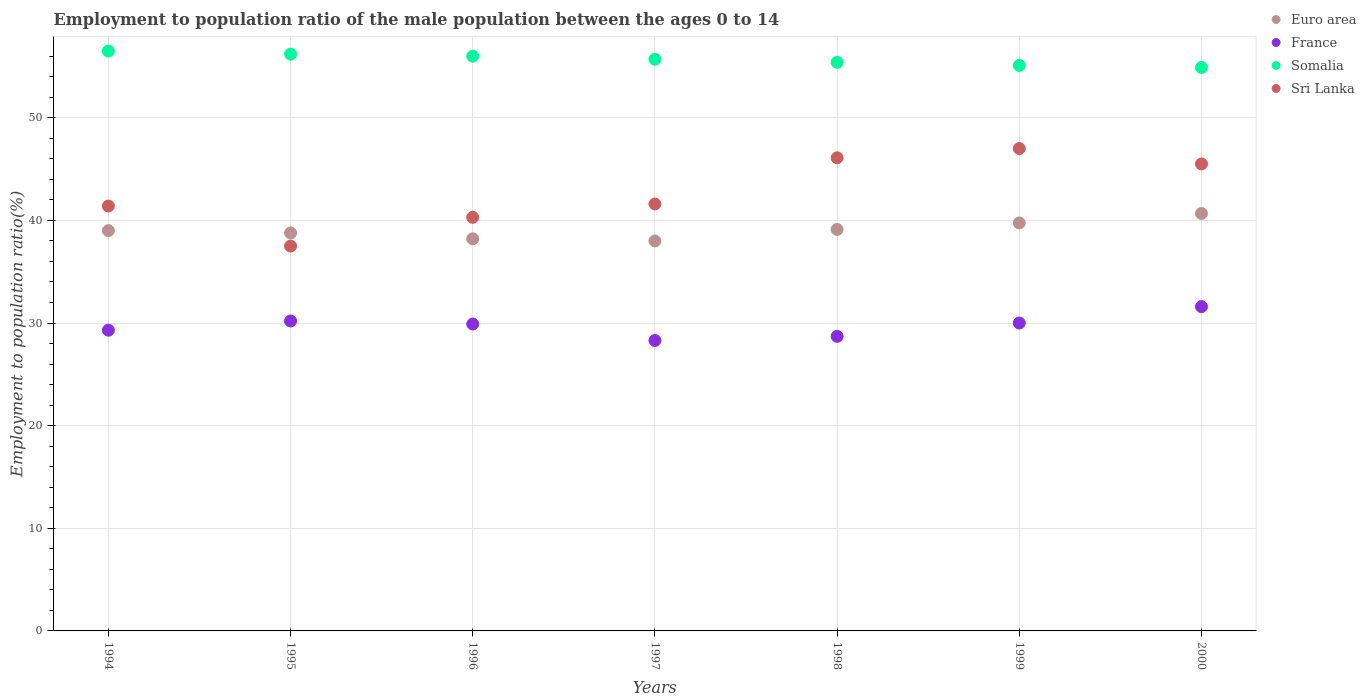Is the number of dotlines equal to the number of legend labels?
Give a very brief answer. Yes. What is the employment to population ratio in Euro area in 1998?
Provide a short and direct response. 39.12. Across all years, what is the maximum employment to population ratio in France?
Offer a very short reply. 31.6. Across all years, what is the minimum employment to population ratio in Euro area?
Your answer should be very brief. 38. In which year was the employment to population ratio in Euro area maximum?
Offer a terse response. 2000. In which year was the employment to population ratio in Euro area minimum?
Provide a short and direct response. 1997. What is the total employment to population ratio in Sri Lanka in the graph?
Your response must be concise. 299.4. What is the difference between the employment to population ratio in Somalia in 1998 and the employment to population ratio in Euro area in 1997?
Offer a very short reply. 17.4. What is the average employment to population ratio in France per year?
Offer a very short reply. 29.71. In the year 1994, what is the difference between the employment to population ratio in Sri Lanka and employment to population ratio in France?
Keep it short and to the point. 12.1. What is the ratio of the employment to population ratio in Euro area in 1995 to that in 2000?
Your answer should be very brief. 0.95. Is the employment to population ratio in Euro area in 1994 less than that in 1999?
Offer a terse response. Yes. What is the difference between the highest and the second highest employment to population ratio in Somalia?
Provide a short and direct response. 0.3. What is the difference between the highest and the lowest employment to population ratio in Euro area?
Your answer should be compact. 2.68. Is the sum of the employment to population ratio in Somalia in 1996 and 1999 greater than the maximum employment to population ratio in France across all years?
Ensure brevity in your answer.  Yes. Is it the case that in every year, the sum of the employment to population ratio in Sri Lanka and employment to population ratio in Euro area  is greater than the sum of employment to population ratio in Somalia and employment to population ratio in France?
Provide a succinct answer. Yes. Is the employment to population ratio in Somalia strictly greater than the employment to population ratio in Euro area over the years?
Give a very brief answer. Yes. Is the employment to population ratio in Euro area strictly less than the employment to population ratio in Somalia over the years?
Offer a terse response. Yes. Are the values on the major ticks of Y-axis written in scientific E-notation?
Give a very brief answer. No. Does the graph contain any zero values?
Ensure brevity in your answer.  No. How many legend labels are there?
Your answer should be very brief. 4. What is the title of the graph?
Provide a succinct answer. Employment to population ratio of the male population between the ages 0 to 14. What is the label or title of the Y-axis?
Offer a very short reply. Employment to population ratio(%). What is the Employment to population ratio(%) in Euro area in 1994?
Your answer should be compact. 39. What is the Employment to population ratio(%) in France in 1994?
Provide a short and direct response. 29.3. What is the Employment to population ratio(%) in Somalia in 1994?
Offer a terse response. 56.5. What is the Employment to population ratio(%) of Sri Lanka in 1994?
Give a very brief answer. 41.4. What is the Employment to population ratio(%) in Euro area in 1995?
Make the answer very short. 38.77. What is the Employment to population ratio(%) of France in 1995?
Give a very brief answer. 30.2. What is the Employment to population ratio(%) in Somalia in 1995?
Offer a very short reply. 56.2. What is the Employment to population ratio(%) in Sri Lanka in 1995?
Your answer should be very brief. 37.5. What is the Employment to population ratio(%) of Euro area in 1996?
Your answer should be compact. 38.21. What is the Employment to population ratio(%) in France in 1996?
Your response must be concise. 29.9. What is the Employment to population ratio(%) in Sri Lanka in 1996?
Ensure brevity in your answer.  40.3. What is the Employment to population ratio(%) of Euro area in 1997?
Offer a very short reply. 38. What is the Employment to population ratio(%) of France in 1997?
Keep it short and to the point. 28.3. What is the Employment to population ratio(%) in Somalia in 1997?
Keep it short and to the point. 55.7. What is the Employment to population ratio(%) of Sri Lanka in 1997?
Offer a terse response. 41.6. What is the Employment to population ratio(%) of Euro area in 1998?
Provide a succinct answer. 39.12. What is the Employment to population ratio(%) of France in 1998?
Give a very brief answer. 28.7. What is the Employment to population ratio(%) of Somalia in 1998?
Provide a succinct answer. 55.4. What is the Employment to population ratio(%) of Sri Lanka in 1998?
Offer a terse response. 46.1. What is the Employment to population ratio(%) in Euro area in 1999?
Your answer should be compact. 39.75. What is the Employment to population ratio(%) in Somalia in 1999?
Provide a succinct answer. 55.1. What is the Employment to population ratio(%) in Euro area in 2000?
Provide a succinct answer. 40.68. What is the Employment to population ratio(%) in France in 2000?
Provide a short and direct response. 31.6. What is the Employment to population ratio(%) in Somalia in 2000?
Give a very brief answer. 54.9. What is the Employment to population ratio(%) in Sri Lanka in 2000?
Provide a succinct answer. 45.5. Across all years, what is the maximum Employment to population ratio(%) of Euro area?
Give a very brief answer. 40.68. Across all years, what is the maximum Employment to population ratio(%) in France?
Give a very brief answer. 31.6. Across all years, what is the maximum Employment to population ratio(%) of Somalia?
Ensure brevity in your answer.  56.5. Across all years, what is the maximum Employment to population ratio(%) in Sri Lanka?
Provide a short and direct response. 47. Across all years, what is the minimum Employment to population ratio(%) of Euro area?
Give a very brief answer. 38. Across all years, what is the minimum Employment to population ratio(%) of France?
Offer a very short reply. 28.3. Across all years, what is the minimum Employment to population ratio(%) in Somalia?
Your answer should be very brief. 54.9. Across all years, what is the minimum Employment to population ratio(%) of Sri Lanka?
Offer a terse response. 37.5. What is the total Employment to population ratio(%) of Euro area in the graph?
Keep it short and to the point. 273.52. What is the total Employment to population ratio(%) of France in the graph?
Your answer should be compact. 208. What is the total Employment to population ratio(%) in Somalia in the graph?
Ensure brevity in your answer.  389.8. What is the total Employment to population ratio(%) of Sri Lanka in the graph?
Offer a terse response. 299.4. What is the difference between the Employment to population ratio(%) of Euro area in 1994 and that in 1995?
Provide a succinct answer. 0.23. What is the difference between the Employment to population ratio(%) in Somalia in 1994 and that in 1995?
Offer a very short reply. 0.3. What is the difference between the Employment to population ratio(%) of Euro area in 1994 and that in 1996?
Your response must be concise. 0.8. What is the difference between the Employment to population ratio(%) of France in 1994 and that in 1996?
Make the answer very short. -0.6. What is the difference between the Employment to population ratio(%) of Euro area in 1994 and that in 1997?
Provide a succinct answer. 1.01. What is the difference between the Employment to population ratio(%) in France in 1994 and that in 1997?
Provide a short and direct response. 1. What is the difference between the Employment to population ratio(%) in Sri Lanka in 1994 and that in 1997?
Provide a short and direct response. -0.2. What is the difference between the Employment to population ratio(%) of Euro area in 1994 and that in 1998?
Your answer should be very brief. -0.12. What is the difference between the Employment to population ratio(%) of Euro area in 1994 and that in 1999?
Your answer should be very brief. -0.75. What is the difference between the Employment to population ratio(%) in Somalia in 1994 and that in 1999?
Provide a succinct answer. 1.4. What is the difference between the Employment to population ratio(%) of Euro area in 1994 and that in 2000?
Ensure brevity in your answer.  -1.67. What is the difference between the Employment to population ratio(%) of France in 1994 and that in 2000?
Ensure brevity in your answer.  -2.3. What is the difference between the Employment to population ratio(%) in Somalia in 1994 and that in 2000?
Offer a terse response. 1.6. What is the difference between the Employment to population ratio(%) of Sri Lanka in 1994 and that in 2000?
Make the answer very short. -4.1. What is the difference between the Employment to population ratio(%) in Euro area in 1995 and that in 1996?
Give a very brief answer. 0.57. What is the difference between the Employment to population ratio(%) of France in 1995 and that in 1996?
Keep it short and to the point. 0.3. What is the difference between the Employment to population ratio(%) of Sri Lanka in 1995 and that in 1996?
Your response must be concise. -2.8. What is the difference between the Employment to population ratio(%) in Euro area in 1995 and that in 1997?
Your answer should be very brief. 0.78. What is the difference between the Employment to population ratio(%) of Euro area in 1995 and that in 1998?
Offer a terse response. -0.34. What is the difference between the Employment to population ratio(%) of Sri Lanka in 1995 and that in 1998?
Ensure brevity in your answer.  -8.6. What is the difference between the Employment to population ratio(%) in Euro area in 1995 and that in 1999?
Provide a succinct answer. -0.98. What is the difference between the Employment to population ratio(%) of France in 1995 and that in 1999?
Your response must be concise. 0.2. What is the difference between the Employment to population ratio(%) of Euro area in 1995 and that in 2000?
Give a very brief answer. -1.9. What is the difference between the Employment to population ratio(%) of France in 1995 and that in 2000?
Give a very brief answer. -1.4. What is the difference between the Employment to population ratio(%) in Euro area in 1996 and that in 1997?
Your answer should be very brief. 0.21. What is the difference between the Employment to population ratio(%) in France in 1996 and that in 1997?
Make the answer very short. 1.6. What is the difference between the Employment to population ratio(%) in Euro area in 1996 and that in 1998?
Provide a short and direct response. -0.91. What is the difference between the Employment to population ratio(%) of France in 1996 and that in 1998?
Your answer should be compact. 1.2. What is the difference between the Employment to population ratio(%) of Euro area in 1996 and that in 1999?
Your answer should be compact. -1.54. What is the difference between the Employment to population ratio(%) of Sri Lanka in 1996 and that in 1999?
Provide a succinct answer. -6.7. What is the difference between the Employment to population ratio(%) of Euro area in 1996 and that in 2000?
Keep it short and to the point. -2.47. What is the difference between the Employment to population ratio(%) in Somalia in 1996 and that in 2000?
Provide a succinct answer. 1.1. What is the difference between the Employment to population ratio(%) in Sri Lanka in 1996 and that in 2000?
Provide a short and direct response. -5.2. What is the difference between the Employment to population ratio(%) in Euro area in 1997 and that in 1998?
Provide a short and direct response. -1.12. What is the difference between the Employment to population ratio(%) in Somalia in 1997 and that in 1998?
Offer a very short reply. 0.3. What is the difference between the Employment to population ratio(%) in Euro area in 1997 and that in 1999?
Give a very brief answer. -1.76. What is the difference between the Employment to population ratio(%) of Euro area in 1997 and that in 2000?
Provide a short and direct response. -2.68. What is the difference between the Employment to population ratio(%) of France in 1997 and that in 2000?
Offer a very short reply. -3.3. What is the difference between the Employment to population ratio(%) in Euro area in 1998 and that in 1999?
Give a very brief answer. -0.63. What is the difference between the Employment to population ratio(%) of Somalia in 1998 and that in 1999?
Your answer should be very brief. 0.3. What is the difference between the Employment to population ratio(%) in Sri Lanka in 1998 and that in 1999?
Your answer should be compact. -0.9. What is the difference between the Employment to population ratio(%) of Euro area in 1998 and that in 2000?
Your answer should be very brief. -1.56. What is the difference between the Employment to population ratio(%) of France in 1998 and that in 2000?
Your answer should be compact. -2.9. What is the difference between the Employment to population ratio(%) of Sri Lanka in 1998 and that in 2000?
Ensure brevity in your answer.  0.6. What is the difference between the Employment to population ratio(%) in Euro area in 1999 and that in 2000?
Keep it short and to the point. -0.92. What is the difference between the Employment to population ratio(%) of Sri Lanka in 1999 and that in 2000?
Keep it short and to the point. 1.5. What is the difference between the Employment to population ratio(%) of Euro area in 1994 and the Employment to population ratio(%) of France in 1995?
Your answer should be compact. 8.8. What is the difference between the Employment to population ratio(%) in Euro area in 1994 and the Employment to population ratio(%) in Somalia in 1995?
Provide a succinct answer. -17.2. What is the difference between the Employment to population ratio(%) of Euro area in 1994 and the Employment to population ratio(%) of Sri Lanka in 1995?
Provide a succinct answer. 1.5. What is the difference between the Employment to population ratio(%) of France in 1994 and the Employment to population ratio(%) of Somalia in 1995?
Provide a succinct answer. -26.9. What is the difference between the Employment to population ratio(%) in Somalia in 1994 and the Employment to population ratio(%) in Sri Lanka in 1995?
Offer a very short reply. 19. What is the difference between the Employment to population ratio(%) in Euro area in 1994 and the Employment to population ratio(%) in France in 1996?
Provide a short and direct response. 9.1. What is the difference between the Employment to population ratio(%) of Euro area in 1994 and the Employment to population ratio(%) of Somalia in 1996?
Provide a succinct answer. -17. What is the difference between the Employment to population ratio(%) in Euro area in 1994 and the Employment to population ratio(%) in Sri Lanka in 1996?
Keep it short and to the point. -1.3. What is the difference between the Employment to population ratio(%) of France in 1994 and the Employment to population ratio(%) of Somalia in 1996?
Your answer should be compact. -26.7. What is the difference between the Employment to population ratio(%) of France in 1994 and the Employment to population ratio(%) of Sri Lanka in 1996?
Keep it short and to the point. -11. What is the difference between the Employment to population ratio(%) of Euro area in 1994 and the Employment to population ratio(%) of France in 1997?
Your answer should be very brief. 10.7. What is the difference between the Employment to population ratio(%) of Euro area in 1994 and the Employment to population ratio(%) of Somalia in 1997?
Offer a very short reply. -16.7. What is the difference between the Employment to population ratio(%) in Euro area in 1994 and the Employment to population ratio(%) in Sri Lanka in 1997?
Ensure brevity in your answer.  -2.6. What is the difference between the Employment to population ratio(%) of France in 1994 and the Employment to population ratio(%) of Somalia in 1997?
Your answer should be very brief. -26.4. What is the difference between the Employment to population ratio(%) of France in 1994 and the Employment to population ratio(%) of Sri Lanka in 1997?
Provide a short and direct response. -12.3. What is the difference between the Employment to population ratio(%) in Somalia in 1994 and the Employment to population ratio(%) in Sri Lanka in 1997?
Give a very brief answer. 14.9. What is the difference between the Employment to population ratio(%) of Euro area in 1994 and the Employment to population ratio(%) of France in 1998?
Your response must be concise. 10.3. What is the difference between the Employment to population ratio(%) in Euro area in 1994 and the Employment to population ratio(%) in Somalia in 1998?
Your response must be concise. -16.4. What is the difference between the Employment to population ratio(%) of Euro area in 1994 and the Employment to population ratio(%) of Sri Lanka in 1998?
Ensure brevity in your answer.  -7.1. What is the difference between the Employment to population ratio(%) of France in 1994 and the Employment to population ratio(%) of Somalia in 1998?
Offer a terse response. -26.1. What is the difference between the Employment to population ratio(%) of France in 1994 and the Employment to population ratio(%) of Sri Lanka in 1998?
Your answer should be compact. -16.8. What is the difference between the Employment to population ratio(%) in Somalia in 1994 and the Employment to population ratio(%) in Sri Lanka in 1998?
Give a very brief answer. 10.4. What is the difference between the Employment to population ratio(%) in Euro area in 1994 and the Employment to population ratio(%) in France in 1999?
Offer a very short reply. 9. What is the difference between the Employment to population ratio(%) in Euro area in 1994 and the Employment to population ratio(%) in Somalia in 1999?
Offer a very short reply. -16.1. What is the difference between the Employment to population ratio(%) of Euro area in 1994 and the Employment to population ratio(%) of Sri Lanka in 1999?
Provide a short and direct response. -8. What is the difference between the Employment to population ratio(%) in France in 1994 and the Employment to population ratio(%) in Somalia in 1999?
Keep it short and to the point. -25.8. What is the difference between the Employment to population ratio(%) in France in 1994 and the Employment to population ratio(%) in Sri Lanka in 1999?
Provide a succinct answer. -17.7. What is the difference between the Employment to population ratio(%) in Somalia in 1994 and the Employment to population ratio(%) in Sri Lanka in 1999?
Provide a succinct answer. 9.5. What is the difference between the Employment to population ratio(%) of Euro area in 1994 and the Employment to population ratio(%) of France in 2000?
Give a very brief answer. 7.4. What is the difference between the Employment to population ratio(%) in Euro area in 1994 and the Employment to population ratio(%) in Somalia in 2000?
Your response must be concise. -15.9. What is the difference between the Employment to population ratio(%) of Euro area in 1994 and the Employment to population ratio(%) of Sri Lanka in 2000?
Make the answer very short. -6.5. What is the difference between the Employment to population ratio(%) of France in 1994 and the Employment to population ratio(%) of Somalia in 2000?
Make the answer very short. -25.6. What is the difference between the Employment to population ratio(%) in France in 1994 and the Employment to population ratio(%) in Sri Lanka in 2000?
Offer a very short reply. -16.2. What is the difference between the Employment to population ratio(%) in Somalia in 1994 and the Employment to population ratio(%) in Sri Lanka in 2000?
Provide a short and direct response. 11. What is the difference between the Employment to population ratio(%) of Euro area in 1995 and the Employment to population ratio(%) of France in 1996?
Your response must be concise. 8.87. What is the difference between the Employment to population ratio(%) of Euro area in 1995 and the Employment to population ratio(%) of Somalia in 1996?
Your answer should be very brief. -17.23. What is the difference between the Employment to population ratio(%) in Euro area in 1995 and the Employment to population ratio(%) in Sri Lanka in 1996?
Your answer should be very brief. -1.53. What is the difference between the Employment to population ratio(%) of France in 1995 and the Employment to population ratio(%) of Somalia in 1996?
Your response must be concise. -25.8. What is the difference between the Employment to population ratio(%) in Somalia in 1995 and the Employment to population ratio(%) in Sri Lanka in 1996?
Provide a short and direct response. 15.9. What is the difference between the Employment to population ratio(%) of Euro area in 1995 and the Employment to population ratio(%) of France in 1997?
Your answer should be compact. 10.47. What is the difference between the Employment to population ratio(%) in Euro area in 1995 and the Employment to population ratio(%) in Somalia in 1997?
Make the answer very short. -16.93. What is the difference between the Employment to population ratio(%) in Euro area in 1995 and the Employment to population ratio(%) in Sri Lanka in 1997?
Offer a terse response. -2.83. What is the difference between the Employment to population ratio(%) of France in 1995 and the Employment to population ratio(%) of Somalia in 1997?
Ensure brevity in your answer.  -25.5. What is the difference between the Employment to population ratio(%) of France in 1995 and the Employment to population ratio(%) of Sri Lanka in 1997?
Your answer should be very brief. -11.4. What is the difference between the Employment to population ratio(%) of Somalia in 1995 and the Employment to population ratio(%) of Sri Lanka in 1997?
Keep it short and to the point. 14.6. What is the difference between the Employment to population ratio(%) of Euro area in 1995 and the Employment to population ratio(%) of France in 1998?
Provide a short and direct response. 10.07. What is the difference between the Employment to population ratio(%) of Euro area in 1995 and the Employment to population ratio(%) of Somalia in 1998?
Ensure brevity in your answer.  -16.63. What is the difference between the Employment to population ratio(%) of Euro area in 1995 and the Employment to population ratio(%) of Sri Lanka in 1998?
Provide a succinct answer. -7.33. What is the difference between the Employment to population ratio(%) of France in 1995 and the Employment to population ratio(%) of Somalia in 1998?
Provide a short and direct response. -25.2. What is the difference between the Employment to population ratio(%) in France in 1995 and the Employment to population ratio(%) in Sri Lanka in 1998?
Keep it short and to the point. -15.9. What is the difference between the Employment to population ratio(%) in Euro area in 1995 and the Employment to population ratio(%) in France in 1999?
Your answer should be very brief. 8.77. What is the difference between the Employment to population ratio(%) in Euro area in 1995 and the Employment to population ratio(%) in Somalia in 1999?
Your answer should be compact. -16.33. What is the difference between the Employment to population ratio(%) in Euro area in 1995 and the Employment to population ratio(%) in Sri Lanka in 1999?
Provide a succinct answer. -8.23. What is the difference between the Employment to population ratio(%) in France in 1995 and the Employment to population ratio(%) in Somalia in 1999?
Offer a very short reply. -24.9. What is the difference between the Employment to population ratio(%) of France in 1995 and the Employment to population ratio(%) of Sri Lanka in 1999?
Provide a succinct answer. -16.8. What is the difference between the Employment to population ratio(%) in Somalia in 1995 and the Employment to population ratio(%) in Sri Lanka in 1999?
Your answer should be compact. 9.2. What is the difference between the Employment to population ratio(%) in Euro area in 1995 and the Employment to population ratio(%) in France in 2000?
Make the answer very short. 7.17. What is the difference between the Employment to population ratio(%) in Euro area in 1995 and the Employment to population ratio(%) in Somalia in 2000?
Keep it short and to the point. -16.13. What is the difference between the Employment to population ratio(%) of Euro area in 1995 and the Employment to population ratio(%) of Sri Lanka in 2000?
Offer a very short reply. -6.73. What is the difference between the Employment to population ratio(%) of France in 1995 and the Employment to population ratio(%) of Somalia in 2000?
Offer a very short reply. -24.7. What is the difference between the Employment to population ratio(%) in France in 1995 and the Employment to population ratio(%) in Sri Lanka in 2000?
Offer a very short reply. -15.3. What is the difference between the Employment to population ratio(%) of Euro area in 1996 and the Employment to population ratio(%) of France in 1997?
Your answer should be very brief. 9.91. What is the difference between the Employment to population ratio(%) in Euro area in 1996 and the Employment to population ratio(%) in Somalia in 1997?
Offer a very short reply. -17.49. What is the difference between the Employment to population ratio(%) in Euro area in 1996 and the Employment to population ratio(%) in Sri Lanka in 1997?
Offer a very short reply. -3.39. What is the difference between the Employment to population ratio(%) in France in 1996 and the Employment to population ratio(%) in Somalia in 1997?
Provide a succinct answer. -25.8. What is the difference between the Employment to population ratio(%) of France in 1996 and the Employment to population ratio(%) of Sri Lanka in 1997?
Ensure brevity in your answer.  -11.7. What is the difference between the Employment to population ratio(%) in Somalia in 1996 and the Employment to population ratio(%) in Sri Lanka in 1997?
Your answer should be compact. 14.4. What is the difference between the Employment to population ratio(%) in Euro area in 1996 and the Employment to population ratio(%) in France in 1998?
Your response must be concise. 9.51. What is the difference between the Employment to population ratio(%) in Euro area in 1996 and the Employment to population ratio(%) in Somalia in 1998?
Make the answer very short. -17.19. What is the difference between the Employment to population ratio(%) in Euro area in 1996 and the Employment to population ratio(%) in Sri Lanka in 1998?
Provide a succinct answer. -7.89. What is the difference between the Employment to population ratio(%) of France in 1996 and the Employment to population ratio(%) of Somalia in 1998?
Offer a terse response. -25.5. What is the difference between the Employment to population ratio(%) in France in 1996 and the Employment to population ratio(%) in Sri Lanka in 1998?
Your response must be concise. -16.2. What is the difference between the Employment to population ratio(%) of Euro area in 1996 and the Employment to population ratio(%) of France in 1999?
Keep it short and to the point. 8.21. What is the difference between the Employment to population ratio(%) of Euro area in 1996 and the Employment to population ratio(%) of Somalia in 1999?
Provide a succinct answer. -16.89. What is the difference between the Employment to population ratio(%) of Euro area in 1996 and the Employment to population ratio(%) of Sri Lanka in 1999?
Give a very brief answer. -8.79. What is the difference between the Employment to population ratio(%) in France in 1996 and the Employment to population ratio(%) in Somalia in 1999?
Offer a terse response. -25.2. What is the difference between the Employment to population ratio(%) in France in 1996 and the Employment to population ratio(%) in Sri Lanka in 1999?
Give a very brief answer. -17.1. What is the difference between the Employment to population ratio(%) of Somalia in 1996 and the Employment to population ratio(%) of Sri Lanka in 1999?
Provide a short and direct response. 9. What is the difference between the Employment to population ratio(%) in Euro area in 1996 and the Employment to population ratio(%) in France in 2000?
Offer a very short reply. 6.61. What is the difference between the Employment to population ratio(%) in Euro area in 1996 and the Employment to population ratio(%) in Somalia in 2000?
Your answer should be very brief. -16.69. What is the difference between the Employment to population ratio(%) in Euro area in 1996 and the Employment to population ratio(%) in Sri Lanka in 2000?
Make the answer very short. -7.29. What is the difference between the Employment to population ratio(%) in France in 1996 and the Employment to population ratio(%) in Sri Lanka in 2000?
Provide a succinct answer. -15.6. What is the difference between the Employment to population ratio(%) in Somalia in 1996 and the Employment to population ratio(%) in Sri Lanka in 2000?
Your answer should be compact. 10.5. What is the difference between the Employment to population ratio(%) in Euro area in 1997 and the Employment to population ratio(%) in France in 1998?
Provide a short and direct response. 9.3. What is the difference between the Employment to population ratio(%) in Euro area in 1997 and the Employment to population ratio(%) in Somalia in 1998?
Ensure brevity in your answer.  -17.4. What is the difference between the Employment to population ratio(%) of Euro area in 1997 and the Employment to population ratio(%) of Sri Lanka in 1998?
Offer a terse response. -8.1. What is the difference between the Employment to population ratio(%) of France in 1997 and the Employment to population ratio(%) of Somalia in 1998?
Ensure brevity in your answer.  -27.1. What is the difference between the Employment to population ratio(%) in France in 1997 and the Employment to population ratio(%) in Sri Lanka in 1998?
Give a very brief answer. -17.8. What is the difference between the Employment to population ratio(%) in Somalia in 1997 and the Employment to population ratio(%) in Sri Lanka in 1998?
Offer a terse response. 9.6. What is the difference between the Employment to population ratio(%) in Euro area in 1997 and the Employment to population ratio(%) in France in 1999?
Offer a very short reply. 8. What is the difference between the Employment to population ratio(%) of Euro area in 1997 and the Employment to population ratio(%) of Somalia in 1999?
Your answer should be very brief. -17.1. What is the difference between the Employment to population ratio(%) in Euro area in 1997 and the Employment to population ratio(%) in Sri Lanka in 1999?
Your response must be concise. -9. What is the difference between the Employment to population ratio(%) of France in 1997 and the Employment to population ratio(%) of Somalia in 1999?
Your response must be concise. -26.8. What is the difference between the Employment to population ratio(%) of France in 1997 and the Employment to population ratio(%) of Sri Lanka in 1999?
Offer a terse response. -18.7. What is the difference between the Employment to population ratio(%) of Somalia in 1997 and the Employment to population ratio(%) of Sri Lanka in 1999?
Make the answer very short. 8.7. What is the difference between the Employment to population ratio(%) in Euro area in 1997 and the Employment to population ratio(%) in France in 2000?
Offer a terse response. 6.4. What is the difference between the Employment to population ratio(%) of Euro area in 1997 and the Employment to population ratio(%) of Somalia in 2000?
Offer a very short reply. -16.9. What is the difference between the Employment to population ratio(%) of Euro area in 1997 and the Employment to population ratio(%) of Sri Lanka in 2000?
Your answer should be very brief. -7.5. What is the difference between the Employment to population ratio(%) of France in 1997 and the Employment to population ratio(%) of Somalia in 2000?
Offer a terse response. -26.6. What is the difference between the Employment to population ratio(%) in France in 1997 and the Employment to population ratio(%) in Sri Lanka in 2000?
Your answer should be compact. -17.2. What is the difference between the Employment to population ratio(%) in Euro area in 1998 and the Employment to population ratio(%) in France in 1999?
Provide a succinct answer. 9.12. What is the difference between the Employment to population ratio(%) of Euro area in 1998 and the Employment to population ratio(%) of Somalia in 1999?
Make the answer very short. -15.98. What is the difference between the Employment to population ratio(%) of Euro area in 1998 and the Employment to population ratio(%) of Sri Lanka in 1999?
Keep it short and to the point. -7.88. What is the difference between the Employment to population ratio(%) of France in 1998 and the Employment to population ratio(%) of Somalia in 1999?
Provide a succinct answer. -26.4. What is the difference between the Employment to population ratio(%) in France in 1998 and the Employment to population ratio(%) in Sri Lanka in 1999?
Your response must be concise. -18.3. What is the difference between the Employment to population ratio(%) of Somalia in 1998 and the Employment to population ratio(%) of Sri Lanka in 1999?
Keep it short and to the point. 8.4. What is the difference between the Employment to population ratio(%) in Euro area in 1998 and the Employment to population ratio(%) in France in 2000?
Give a very brief answer. 7.52. What is the difference between the Employment to population ratio(%) of Euro area in 1998 and the Employment to population ratio(%) of Somalia in 2000?
Your response must be concise. -15.78. What is the difference between the Employment to population ratio(%) in Euro area in 1998 and the Employment to population ratio(%) in Sri Lanka in 2000?
Your response must be concise. -6.38. What is the difference between the Employment to population ratio(%) in France in 1998 and the Employment to population ratio(%) in Somalia in 2000?
Your answer should be very brief. -26.2. What is the difference between the Employment to population ratio(%) of France in 1998 and the Employment to population ratio(%) of Sri Lanka in 2000?
Offer a very short reply. -16.8. What is the difference between the Employment to population ratio(%) of Somalia in 1998 and the Employment to population ratio(%) of Sri Lanka in 2000?
Give a very brief answer. 9.9. What is the difference between the Employment to population ratio(%) of Euro area in 1999 and the Employment to population ratio(%) of France in 2000?
Make the answer very short. 8.15. What is the difference between the Employment to population ratio(%) in Euro area in 1999 and the Employment to population ratio(%) in Somalia in 2000?
Offer a terse response. -15.15. What is the difference between the Employment to population ratio(%) of Euro area in 1999 and the Employment to population ratio(%) of Sri Lanka in 2000?
Your answer should be compact. -5.75. What is the difference between the Employment to population ratio(%) of France in 1999 and the Employment to population ratio(%) of Somalia in 2000?
Make the answer very short. -24.9. What is the difference between the Employment to population ratio(%) in France in 1999 and the Employment to population ratio(%) in Sri Lanka in 2000?
Provide a short and direct response. -15.5. What is the difference between the Employment to population ratio(%) in Somalia in 1999 and the Employment to population ratio(%) in Sri Lanka in 2000?
Ensure brevity in your answer.  9.6. What is the average Employment to population ratio(%) in Euro area per year?
Ensure brevity in your answer.  39.07. What is the average Employment to population ratio(%) in France per year?
Your response must be concise. 29.71. What is the average Employment to population ratio(%) of Somalia per year?
Ensure brevity in your answer.  55.69. What is the average Employment to population ratio(%) in Sri Lanka per year?
Make the answer very short. 42.77. In the year 1994, what is the difference between the Employment to population ratio(%) in Euro area and Employment to population ratio(%) in France?
Give a very brief answer. 9.7. In the year 1994, what is the difference between the Employment to population ratio(%) in Euro area and Employment to population ratio(%) in Somalia?
Provide a succinct answer. -17.5. In the year 1994, what is the difference between the Employment to population ratio(%) of Euro area and Employment to population ratio(%) of Sri Lanka?
Offer a very short reply. -2.4. In the year 1994, what is the difference between the Employment to population ratio(%) of France and Employment to population ratio(%) of Somalia?
Provide a short and direct response. -27.2. In the year 1994, what is the difference between the Employment to population ratio(%) in Somalia and Employment to population ratio(%) in Sri Lanka?
Make the answer very short. 15.1. In the year 1995, what is the difference between the Employment to population ratio(%) of Euro area and Employment to population ratio(%) of France?
Your answer should be compact. 8.57. In the year 1995, what is the difference between the Employment to population ratio(%) in Euro area and Employment to population ratio(%) in Somalia?
Offer a terse response. -17.43. In the year 1995, what is the difference between the Employment to population ratio(%) in Euro area and Employment to population ratio(%) in Sri Lanka?
Offer a very short reply. 1.27. In the year 1995, what is the difference between the Employment to population ratio(%) of France and Employment to population ratio(%) of Somalia?
Offer a very short reply. -26. In the year 1996, what is the difference between the Employment to population ratio(%) in Euro area and Employment to population ratio(%) in France?
Keep it short and to the point. 8.31. In the year 1996, what is the difference between the Employment to population ratio(%) in Euro area and Employment to population ratio(%) in Somalia?
Keep it short and to the point. -17.79. In the year 1996, what is the difference between the Employment to population ratio(%) in Euro area and Employment to population ratio(%) in Sri Lanka?
Ensure brevity in your answer.  -2.09. In the year 1996, what is the difference between the Employment to population ratio(%) in France and Employment to population ratio(%) in Somalia?
Offer a very short reply. -26.1. In the year 1996, what is the difference between the Employment to population ratio(%) of France and Employment to population ratio(%) of Sri Lanka?
Make the answer very short. -10.4. In the year 1996, what is the difference between the Employment to population ratio(%) in Somalia and Employment to population ratio(%) in Sri Lanka?
Make the answer very short. 15.7. In the year 1997, what is the difference between the Employment to population ratio(%) in Euro area and Employment to population ratio(%) in France?
Your answer should be compact. 9.7. In the year 1997, what is the difference between the Employment to population ratio(%) in Euro area and Employment to population ratio(%) in Somalia?
Ensure brevity in your answer.  -17.7. In the year 1997, what is the difference between the Employment to population ratio(%) of Euro area and Employment to population ratio(%) of Sri Lanka?
Provide a succinct answer. -3.6. In the year 1997, what is the difference between the Employment to population ratio(%) in France and Employment to population ratio(%) in Somalia?
Keep it short and to the point. -27.4. In the year 1997, what is the difference between the Employment to population ratio(%) in Somalia and Employment to population ratio(%) in Sri Lanka?
Provide a short and direct response. 14.1. In the year 1998, what is the difference between the Employment to population ratio(%) of Euro area and Employment to population ratio(%) of France?
Keep it short and to the point. 10.42. In the year 1998, what is the difference between the Employment to population ratio(%) in Euro area and Employment to population ratio(%) in Somalia?
Your answer should be compact. -16.28. In the year 1998, what is the difference between the Employment to population ratio(%) of Euro area and Employment to population ratio(%) of Sri Lanka?
Make the answer very short. -6.98. In the year 1998, what is the difference between the Employment to population ratio(%) in France and Employment to population ratio(%) in Somalia?
Provide a short and direct response. -26.7. In the year 1998, what is the difference between the Employment to population ratio(%) of France and Employment to population ratio(%) of Sri Lanka?
Your answer should be compact. -17.4. In the year 1999, what is the difference between the Employment to population ratio(%) in Euro area and Employment to population ratio(%) in France?
Ensure brevity in your answer.  9.75. In the year 1999, what is the difference between the Employment to population ratio(%) in Euro area and Employment to population ratio(%) in Somalia?
Your answer should be very brief. -15.35. In the year 1999, what is the difference between the Employment to population ratio(%) of Euro area and Employment to population ratio(%) of Sri Lanka?
Make the answer very short. -7.25. In the year 1999, what is the difference between the Employment to population ratio(%) of France and Employment to population ratio(%) of Somalia?
Give a very brief answer. -25.1. In the year 1999, what is the difference between the Employment to population ratio(%) in France and Employment to population ratio(%) in Sri Lanka?
Ensure brevity in your answer.  -17. In the year 2000, what is the difference between the Employment to population ratio(%) of Euro area and Employment to population ratio(%) of France?
Offer a terse response. 9.08. In the year 2000, what is the difference between the Employment to population ratio(%) of Euro area and Employment to population ratio(%) of Somalia?
Provide a succinct answer. -14.22. In the year 2000, what is the difference between the Employment to population ratio(%) of Euro area and Employment to population ratio(%) of Sri Lanka?
Keep it short and to the point. -4.82. In the year 2000, what is the difference between the Employment to population ratio(%) in France and Employment to population ratio(%) in Somalia?
Provide a succinct answer. -23.3. In the year 2000, what is the difference between the Employment to population ratio(%) of France and Employment to population ratio(%) of Sri Lanka?
Provide a short and direct response. -13.9. In the year 2000, what is the difference between the Employment to population ratio(%) in Somalia and Employment to population ratio(%) in Sri Lanka?
Provide a succinct answer. 9.4. What is the ratio of the Employment to population ratio(%) of Euro area in 1994 to that in 1995?
Your answer should be very brief. 1.01. What is the ratio of the Employment to population ratio(%) of France in 1994 to that in 1995?
Offer a terse response. 0.97. What is the ratio of the Employment to population ratio(%) in Sri Lanka in 1994 to that in 1995?
Your answer should be very brief. 1.1. What is the ratio of the Employment to population ratio(%) in Euro area in 1994 to that in 1996?
Provide a succinct answer. 1.02. What is the ratio of the Employment to population ratio(%) of France in 1994 to that in 1996?
Provide a short and direct response. 0.98. What is the ratio of the Employment to population ratio(%) in Somalia in 1994 to that in 1996?
Give a very brief answer. 1.01. What is the ratio of the Employment to population ratio(%) of Sri Lanka in 1994 to that in 1996?
Ensure brevity in your answer.  1.03. What is the ratio of the Employment to population ratio(%) of Euro area in 1994 to that in 1997?
Give a very brief answer. 1.03. What is the ratio of the Employment to population ratio(%) in France in 1994 to that in 1997?
Ensure brevity in your answer.  1.04. What is the ratio of the Employment to population ratio(%) in Somalia in 1994 to that in 1997?
Provide a short and direct response. 1.01. What is the ratio of the Employment to population ratio(%) of Euro area in 1994 to that in 1998?
Make the answer very short. 1. What is the ratio of the Employment to population ratio(%) in France in 1994 to that in 1998?
Provide a succinct answer. 1.02. What is the ratio of the Employment to population ratio(%) of Somalia in 1994 to that in 1998?
Give a very brief answer. 1.02. What is the ratio of the Employment to population ratio(%) in Sri Lanka in 1994 to that in 1998?
Keep it short and to the point. 0.9. What is the ratio of the Employment to population ratio(%) in Euro area in 1994 to that in 1999?
Provide a succinct answer. 0.98. What is the ratio of the Employment to population ratio(%) of France in 1994 to that in 1999?
Offer a very short reply. 0.98. What is the ratio of the Employment to population ratio(%) in Somalia in 1994 to that in 1999?
Offer a terse response. 1.03. What is the ratio of the Employment to population ratio(%) of Sri Lanka in 1994 to that in 1999?
Your answer should be very brief. 0.88. What is the ratio of the Employment to population ratio(%) of Euro area in 1994 to that in 2000?
Keep it short and to the point. 0.96. What is the ratio of the Employment to population ratio(%) of France in 1994 to that in 2000?
Your answer should be compact. 0.93. What is the ratio of the Employment to population ratio(%) in Somalia in 1994 to that in 2000?
Provide a succinct answer. 1.03. What is the ratio of the Employment to population ratio(%) in Sri Lanka in 1994 to that in 2000?
Provide a short and direct response. 0.91. What is the ratio of the Employment to population ratio(%) in Euro area in 1995 to that in 1996?
Keep it short and to the point. 1.01. What is the ratio of the Employment to population ratio(%) of Somalia in 1995 to that in 1996?
Offer a very short reply. 1. What is the ratio of the Employment to population ratio(%) in Sri Lanka in 1995 to that in 1996?
Keep it short and to the point. 0.93. What is the ratio of the Employment to population ratio(%) of Euro area in 1995 to that in 1997?
Your response must be concise. 1.02. What is the ratio of the Employment to population ratio(%) of France in 1995 to that in 1997?
Ensure brevity in your answer.  1.07. What is the ratio of the Employment to population ratio(%) of Sri Lanka in 1995 to that in 1997?
Keep it short and to the point. 0.9. What is the ratio of the Employment to population ratio(%) in Euro area in 1995 to that in 1998?
Give a very brief answer. 0.99. What is the ratio of the Employment to population ratio(%) in France in 1995 to that in 1998?
Provide a succinct answer. 1.05. What is the ratio of the Employment to population ratio(%) in Somalia in 1995 to that in 1998?
Your answer should be very brief. 1.01. What is the ratio of the Employment to population ratio(%) of Sri Lanka in 1995 to that in 1998?
Make the answer very short. 0.81. What is the ratio of the Employment to population ratio(%) of Euro area in 1995 to that in 1999?
Keep it short and to the point. 0.98. What is the ratio of the Employment to population ratio(%) in Sri Lanka in 1995 to that in 1999?
Offer a terse response. 0.8. What is the ratio of the Employment to population ratio(%) in Euro area in 1995 to that in 2000?
Keep it short and to the point. 0.95. What is the ratio of the Employment to population ratio(%) in France in 1995 to that in 2000?
Provide a short and direct response. 0.96. What is the ratio of the Employment to population ratio(%) in Somalia in 1995 to that in 2000?
Your answer should be compact. 1.02. What is the ratio of the Employment to population ratio(%) of Sri Lanka in 1995 to that in 2000?
Keep it short and to the point. 0.82. What is the ratio of the Employment to population ratio(%) in Euro area in 1996 to that in 1997?
Your answer should be compact. 1.01. What is the ratio of the Employment to population ratio(%) of France in 1996 to that in 1997?
Offer a very short reply. 1.06. What is the ratio of the Employment to population ratio(%) in Somalia in 1996 to that in 1997?
Make the answer very short. 1.01. What is the ratio of the Employment to population ratio(%) of Sri Lanka in 1996 to that in 1997?
Ensure brevity in your answer.  0.97. What is the ratio of the Employment to population ratio(%) in Euro area in 1996 to that in 1998?
Offer a very short reply. 0.98. What is the ratio of the Employment to population ratio(%) of France in 1996 to that in 1998?
Your response must be concise. 1.04. What is the ratio of the Employment to population ratio(%) in Somalia in 1996 to that in 1998?
Offer a terse response. 1.01. What is the ratio of the Employment to population ratio(%) of Sri Lanka in 1996 to that in 1998?
Keep it short and to the point. 0.87. What is the ratio of the Employment to population ratio(%) of Euro area in 1996 to that in 1999?
Your answer should be very brief. 0.96. What is the ratio of the Employment to population ratio(%) in France in 1996 to that in 1999?
Your response must be concise. 1. What is the ratio of the Employment to population ratio(%) in Somalia in 1996 to that in 1999?
Ensure brevity in your answer.  1.02. What is the ratio of the Employment to population ratio(%) of Sri Lanka in 1996 to that in 1999?
Your answer should be compact. 0.86. What is the ratio of the Employment to population ratio(%) of Euro area in 1996 to that in 2000?
Offer a terse response. 0.94. What is the ratio of the Employment to population ratio(%) of France in 1996 to that in 2000?
Provide a short and direct response. 0.95. What is the ratio of the Employment to population ratio(%) in Somalia in 1996 to that in 2000?
Make the answer very short. 1.02. What is the ratio of the Employment to population ratio(%) of Sri Lanka in 1996 to that in 2000?
Give a very brief answer. 0.89. What is the ratio of the Employment to population ratio(%) of Euro area in 1997 to that in 1998?
Give a very brief answer. 0.97. What is the ratio of the Employment to population ratio(%) of France in 1997 to that in 1998?
Make the answer very short. 0.99. What is the ratio of the Employment to population ratio(%) in Somalia in 1997 to that in 1998?
Provide a succinct answer. 1.01. What is the ratio of the Employment to population ratio(%) in Sri Lanka in 1997 to that in 1998?
Your answer should be compact. 0.9. What is the ratio of the Employment to population ratio(%) in Euro area in 1997 to that in 1999?
Offer a very short reply. 0.96. What is the ratio of the Employment to population ratio(%) of France in 1997 to that in 1999?
Provide a succinct answer. 0.94. What is the ratio of the Employment to population ratio(%) in Somalia in 1997 to that in 1999?
Ensure brevity in your answer.  1.01. What is the ratio of the Employment to population ratio(%) of Sri Lanka in 1997 to that in 1999?
Keep it short and to the point. 0.89. What is the ratio of the Employment to population ratio(%) in Euro area in 1997 to that in 2000?
Keep it short and to the point. 0.93. What is the ratio of the Employment to population ratio(%) of France in 1997 to that in 2000?
Your answer should be compact. 0.9. What is the ratio of the Employment to population ratio(%) of Somalia in 1997 to that in 2000?
Provide a short and direct response. 1.01. What is the ratio of the Employment to population ratio(%) in Sri Lanka in 1997 to that in 2000?
Offer a terse response. 0.91. What is the ratio of the Employment to population ratio(%) of Euro area in 1998 to that in 1999?
Give a very brief answer. 0.98. What is the ratio of the Employment to population ratio(%) of France in 1998 to that in 1999?
Provide a short and direct response. 0.96. What is the ratio of the Employment to population ratio(%) in Somalia in 1998 to that in 1999?
Your answer should be very brief. 1.01. What is the ratio of the Employment to population ratio(%) of Sri Lanka in 1998 to that in 1999?
Make the answer very short. 0.98. What is the ratio of the Employment to population ratio(%) in Euro area in 1998 to that in 2000?
Ensure brevity in your answer.  0.96. What is the ratio of the Employment to population ratio(%) of France in 1998 to that in 2000?
Offer a very short reply. 0.91. What is the ratio of the Employment to population ratio(%) in Somalia in 1998 to that in 2000?
Keep it short and to the point. 1.01. What is the ratio of the Employment to population ratio(%) in Sri Lanka in 1998 to that in 2000?
Offer a very short reply. 1.01. What is the ratio of the Employment to population ratio(%) of Euro area in 1999 to that in 2000?
Your response must be concise. 0.98. What is the ratio of the Employment to population ratio(%) in France in 1999 to that in 2000?
Provide a succinct answer. 0.95. What is the ratio of the Employment to population ratio(%) of Sri Lanka in 1999 to that in 2000?
Keep it short and to the point. 1.03. What is the difference between the highest and the second highest Employment to population ratio(%) in Euro area?
Make the answer very short. 0.92. What is the difference between the highest and the second highest Employment to population ratio(%) of France?
Provide a short and direct response. 1.4. What is the difference between the highest and the second highest Employment to population ratio(%) in Somalia?
Make the answer very short. 0.3. What is the difference between the highest and the lowest Employment to population ratio(%) of Euro area?
Give a very brief answer. 2.68. What is the difference between the highest and the lowest Employment to population ratio(%) of France?
Give a very brief answer. 3.3. 